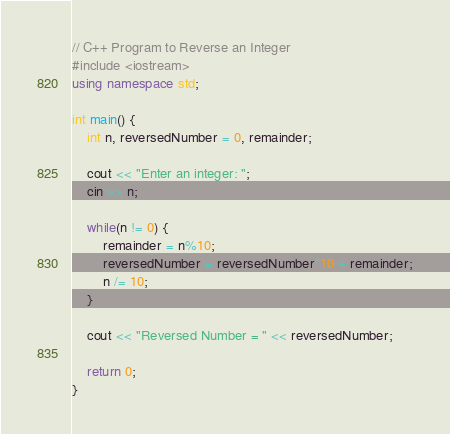<code> <loc_0><loc_0><loc_500><loc_500><_C++_>// C++ Program to Reverse an Integer
#include <iostream>
using namespace std;

int main() {
    int n, reversedNumber = 0, remainder;

    cout << "Enter an integer: ";
    cin >> n;

    while(n != 0) {
        remainder = n%10;
        reversedNumber = reversedNumber*10 + remainder;
        n /= 10;
    }

    cout << "Reversed Number = " << reversedNumber;

    return 0;
}</code> 